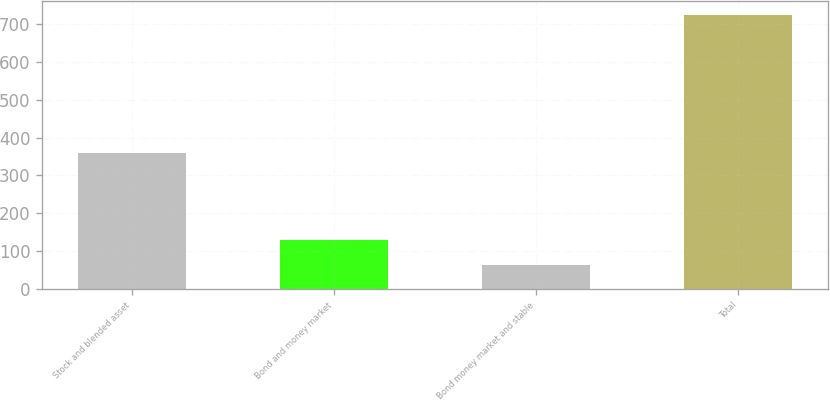Convert chart. <chart><loc_0><loc_0><loc_500><loc_500><bar_chart><fcel>Stock and blended asset<fcel>Bond and money market<fcel>Bond money market and stable<fcel>Total<nl><fcel>359.3<fcel>128.45<fcel>62.2<fcel>724.7<nl></chart> 